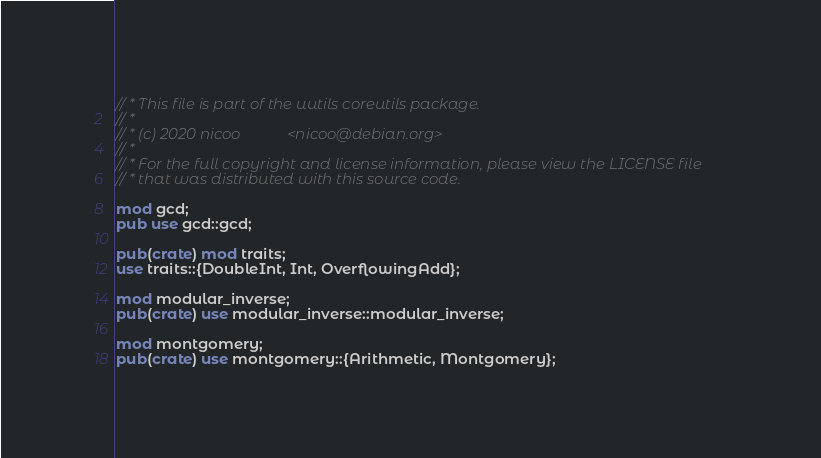Convert code to text. <code><loc_0><loc_0><loc_500><loc_500><_Rust_>// * This file is part of the uutils coreutils package.
// *
// * (c) 2020 nicoo            <nicoo@debian.org>
// *
// * For the full copyright and license information, please view the LICENSE file
// * that was distributed with this source code.

mod gcd;
pub use gcd::gcd;

pub(crate) mod traits;
use traits::{DoubleInt, Int, OverflowingAdd};

mod modular_inverse;
pub(crate) use modular_inverse::modular_inverse;

mod montgomery;
pub(crate) use montgomery::{Arithmetic, Montgomery};
</code> 